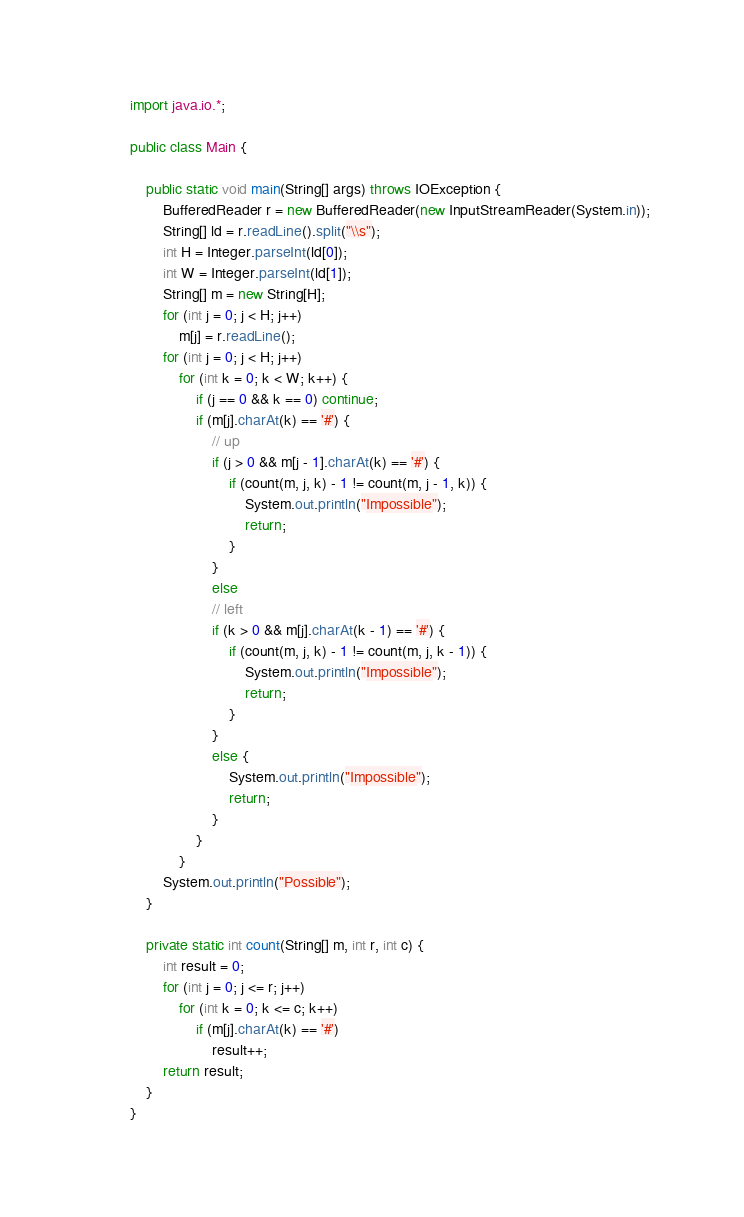<code> <loc_0><loc_0><loc_500><loc_500><_Java_>import java.io.*;

public class Main {

	public static void main(String[] args) throws IOException {
		BufferedReader r = new BufferedReader(new InputStreamReader(System.in));
		String[] ld = r.readLine().split("\\s");
		int H = Integer.parseInt(ld[0]);
		int W = Integer.parseInt(ld[1]);
		String[] m = new String[H];
		for (int j = 0; j < H; j++)
			m[j] = r.readLine();
		for (int j = 0; j < H; j++)
			for (int k = 0; k < W; k++) {
				if (j == 0 && k == 0) continue;
				if (m[j].charAt(k) == '#') {
					// up
					if (j > 0 && m[j - 1].charAt(k) == '#') {
						if (count(m, j, k) - 1 != count(m, j - 1, k)) {
							System.out.println("Impossible");
							return;
						}
					}
					else
					// left
					if (k > 0 && m[j].charAt(k - 1) == '#') {
						if (count(m, j, k) - 1 != count(m, j, k - 1)) {
							System.out.println("Impossible");
							return;
						}
					}
					else {
						System.out.println("Impossible");
						return;
					}
				}
			}
		System.out.println("Possible");
	}

	private static int count(String[] m, int r, int c) {
		int result = 0;
		for (int j = 0; j <= r; j++)
			for (int k = 0; k <= c; k++)
				if (m[j].charAt(k) == '#')
					result++;
		return result;
	}
}</code> 